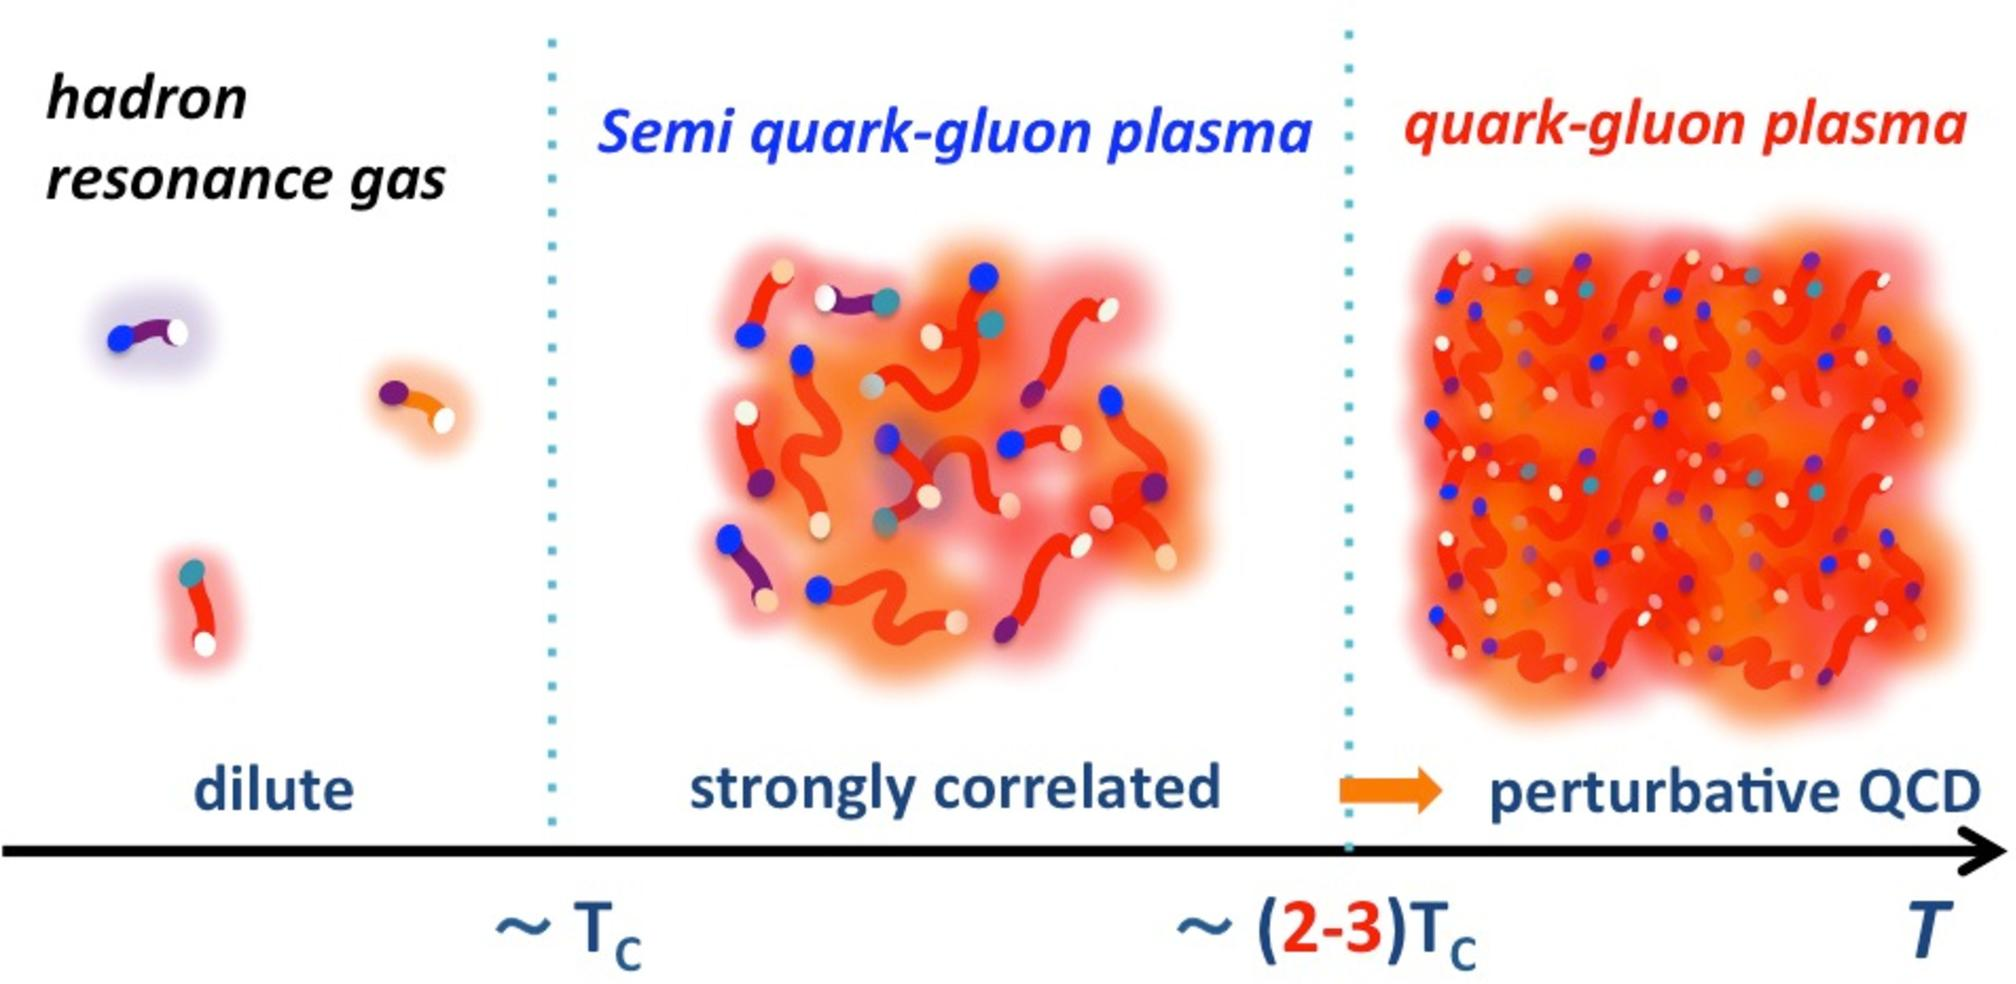How does the changing state from hadron resonance gas to semi quark-gluon plasma impact the observable properties of the matter? The transition from a hadron resonance gas to a semi quark-gluon plasma significantly impacts the observable properties such as viscoelasticity and opacity. In the hadron resonance gas phase, matter behaves more like a conventional gas with hadrons as the dominant components. Once it shifts into the semi quark-gluon phase, the matter starts showing properties of a fluid where quarks and gluons are loosely coupled, leading to changes in how these particles absorb and scatter light. 